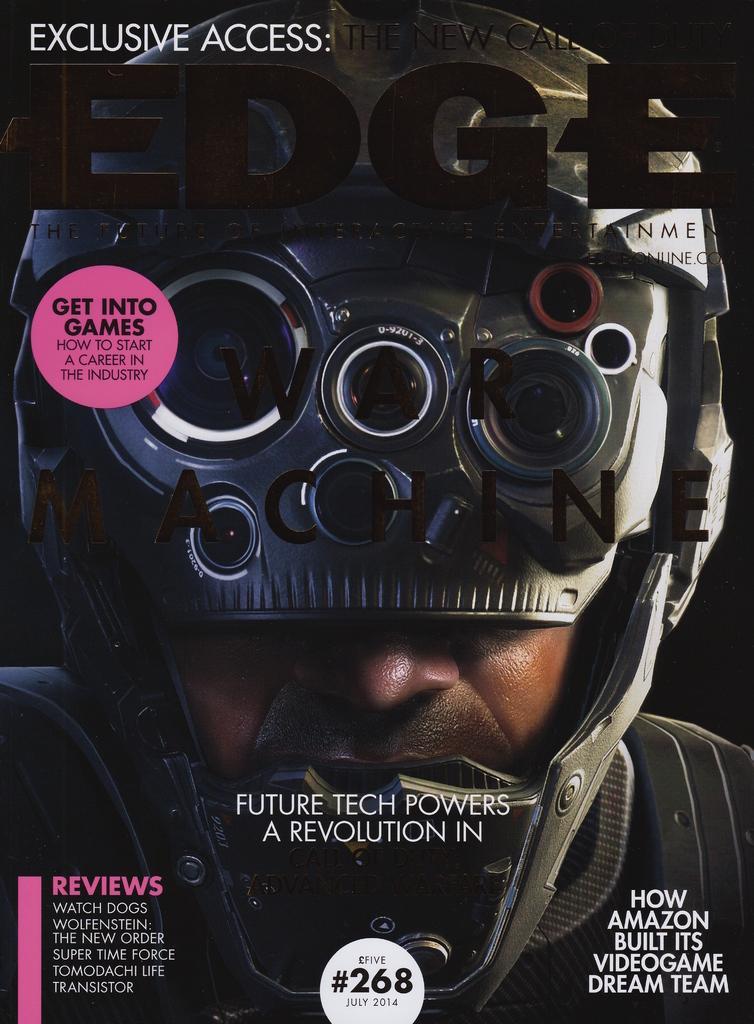How would you summarize this image in a sentence or two? In this picture we can see a man here, he wore a helmet, we can see some text here. 